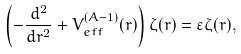<formula> <loc_0><loc_0><loc_500><loc_500>\left ( - \frac { d ^ { 2 } } { d r ^ { 2 } } + V _ { e f f } ^ { ( A - 1 ) } ( r ) \right ) \zeta ( r ) = \varepsilon \zeta ( r ) ,</formula> 